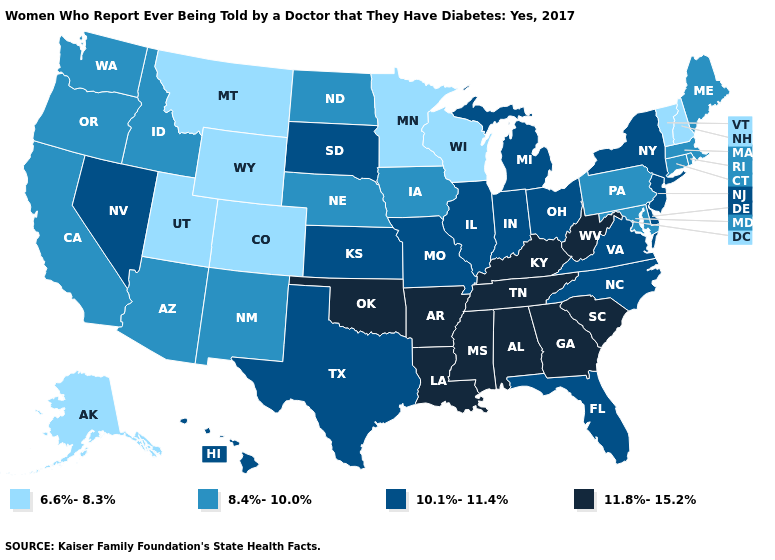Name the states that have a value in the range 6.6%-8.3%?
Keep it brief. Alaska, Colorado, Minnesota, Montana, New Hampshire, Utah, Vermont, Wisconsin, Wyoming. Does the first symbol in the legend represent the smallest category?
Give a very brief answer. Yes. What is the value of Virginia?
Quick response, please. 10.1%-11.4%. Which states have the lowest value in the USA?
Be succinct. Alaska, Colorado, Minnesota, Montana, New Hampshire, Utah, Vermont, Wisconsin, Wyoming. What is the highest value in the USA?
Be succinct. 11.8%-15.2%. Does the first symbol in the legend represent the smallest category?
Quick response, please. Yes. How many symbols are there in the legend?
Be succinct. 4. What is the value of Kentucky?
Quick response, please. 11.8%-15.2%. What is the highest value in the West ?
Be succinct. 10.1%-11.4%. What is the value of Rhode Island?
Write a very short answer. 8.4%-10.0%. Does North Carolina have the highest value in the USA?
Be succinct. No. Name the states that have a value in the range 10.1%-11.4%?
Quick response, please. Delaware, Florida, Hawaii, Illinois, Indiana, Kansas, Michigan, Missouri, Nevada, New Jersey, New York, North Carolina, Ohio, South Dakota, Texas, Virginia. Does Delaware have a lower value than New Jersey?
Keep it brief. No. Does the map have missing data?
Be succinct. No. What is the value of Maine?
Keep it brief. 8.4%-10.0%. 